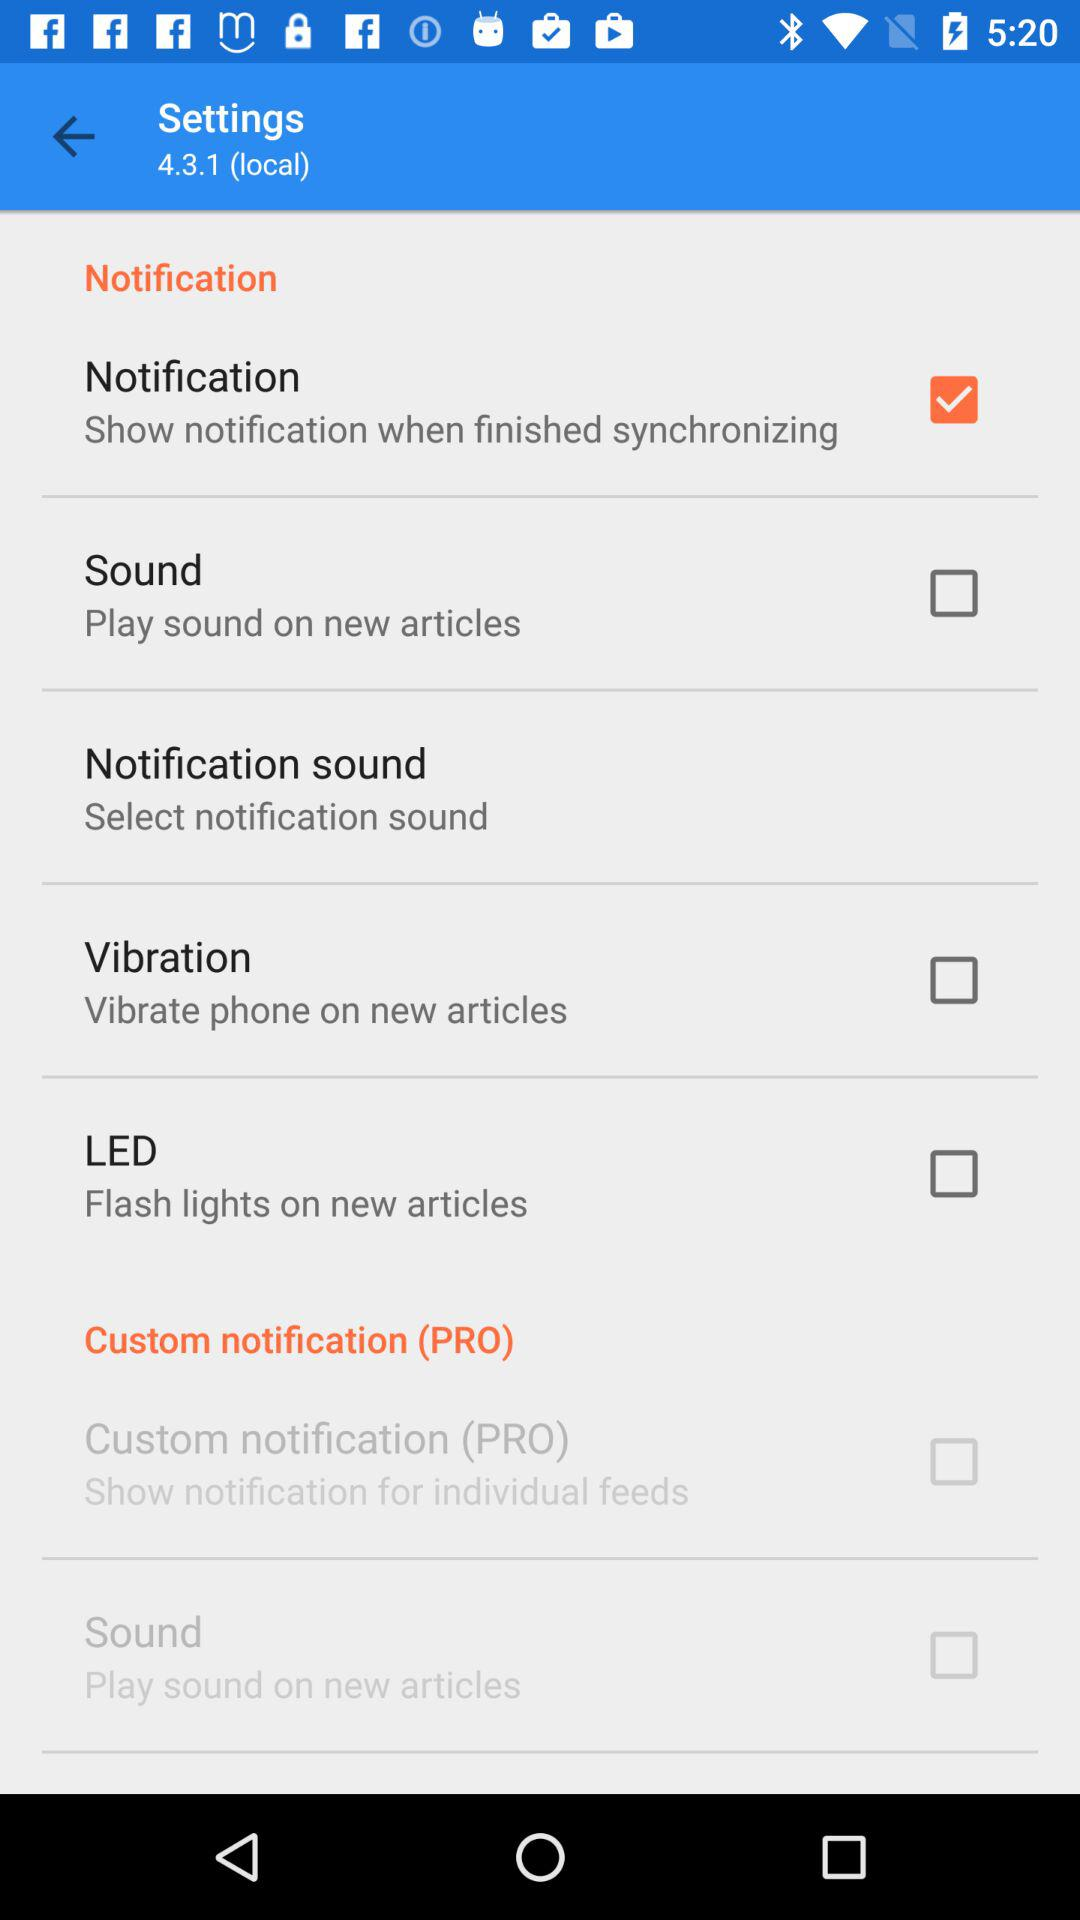What is the current condition of the "Vibration"? The current condition is "off". 